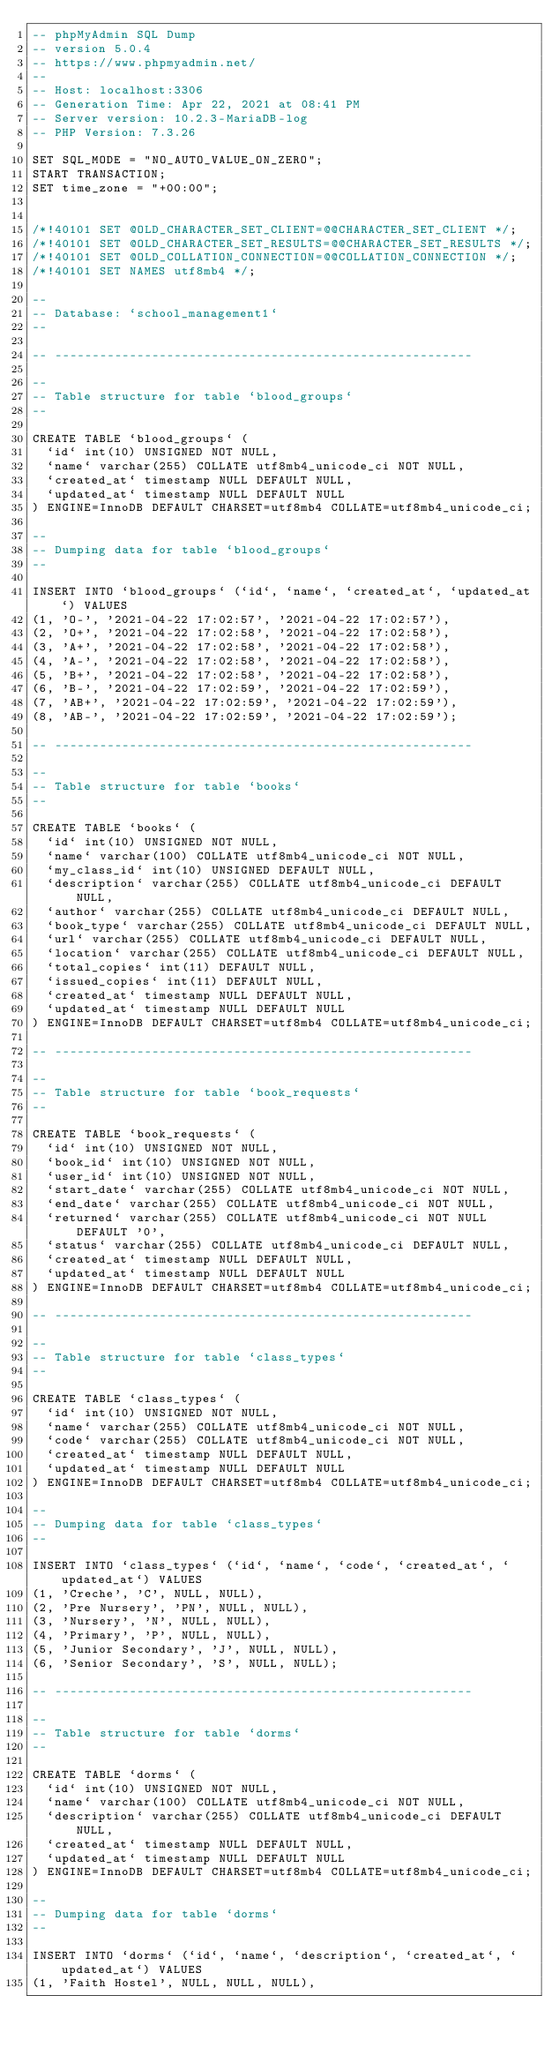<code> <loc_0><loc_0><loc_500><loc_500><_SQL_>-- phpMyAdmin SQL Dump
-- version 5.0.4
-- https://www.phpmyadmin.net/
--
-- Host: localhost:3306
-- Generation Time: Apr 22, 2021 at 08:41 PM
-- Server version: 10.2.3-MariaDB-log
-- PHP Version: 7.3.26

SET SQL_MODE = "NO_AUTO_VALUE_ON_ZERO";
START TRANSACTION;
SET time_zone = "+00:00";


/*!40101 SET @OLD_CHARACTER_SET_CLIENT=@@CHARACTER_SET_CLIENT */;
/*!40101 SET @OLD_CHARACTER_SET_RESULTS=@@CHARACTER_SET_RESULTS */;
/*!40101 SET @OLD_COLLATION_CONNECTION=@@COLLATION_CONNECTION */;
/*!40101 SET NAMES utf8mb4 */;

--
-- Database: `school_management1`
--

-- --------------------------------------------------------

--
-- Table structure for table `blood_groups`
--

CREATE TABLE `blood_groups` (
  `id` int(10) UNSIGNED NOT NULL,
  `name` varchar(255) COLLATE utf8mb4_unicode_ci NOT NULL,
  `created_at` timestamp NULL DEFAULT NULL,
  `updated_at` timestamp NULL DEFAULT NULL
) ENGINE=InnoDB DEFAULT CHARSET=utf8mb4 COLLATE=utf8mb4_unicode_ci;

--
-- Dumping data for table `blood_groups`
--

INSERT INTO `blood_groups` (`id`, `name`, `created_at`, `updated_at`) VALUES
(1, 'O-', '2021-04-22 17:02:57', '2021-04-22 17:02:57'),
(2, 'O+', '2021-04-22 17:02:58', '2021-04-22 17:02:58'),
(3, 'A+', '2021-04-22 17:02:58', '2021-04-22 17:02:58'),
(4, 'A-', '2021-04-22 17:02:58', '2021-04-22 17:02:58'),
(5, 'B+', '2021-04-22 17:02:58', '2021-04-22 17:02:58'),
(6, 'B-', '2021-04-22 17:02:59', '2021-04-22 17:02:59'),
(7, 'AB+', '2021-04-22 17:02:59', '2021-04-22 17:02:59'),
(8, 'AB-', '2021-04-22 17:02:59', '2021-04-22 17:02:59');

-- --------------------------------------------------------

--
-- Table structure for table `books`
--

CREATE TABLE `books` (
  `id` int(10) UNSIGNED NOT NULL,
  `name` varchar(100) COLLATE utf8mb4_unicode_ci NOT NULL,
  `my_class_id` int(10) UNSIGNED DEFAULT NULL,
  `description` varchar(255) COLLATE utf8mb4_unicode_ci DEFAULT NULL,
  `author` varchar(255) COLLATE utf8mb4_unicode_ci DEFAULT NULL,
  `book_type` varchar(255) COLLATE utf8mb4_unicode_ci DEFAULT NULL,
  `url` varchar(255) COLLATE utf8mb4_unicode_ci DEFAULT NULL,
  `location` varchar(255) COLLATE utf8mb4_unicode_ci DEFAULT NULL,
  `total_copies` int(11) DEFAULT NULL,
  `issued_copies` int(11) DEFAULT NULL,
  `created_at` timestamp NULL DEFAULT NULL,
  `updated_at` timestamp NULL DEFAULT NULL
) ENGINE=InnoDB DEFAULT CHARSET=utf8mb4 COLLATE=utf8mb4_unicode_ci;

-- --------------------------------------------------------

--
-- Table structure for table `book_requests`
--

CREATE TABLE `book_requests` (
  `id` int(10) UNSIGNED NOT NULL,
  `book_id` int(10) UNSIGNED NOT NULL,
  `user_id` int(10) UNSIGNED NOT NULL,
  `start_date` varchar(255) COLLATE utf8mb4_unicode_ci NOT NULL,
  `end_date` varchar(255) COLLATE utf8mb4_unicode_ci NOT NULL,
  `returned` varchar(255) COLLATE utf8mb4_unicode_ci NOT NULL DEFAULT '0',
  `status` varchar(255) COLLATE utf8mb4_unicode_ci DEFAULT NULL,
  `created_at` timestamp NULL DEFAULT NULL,
  `updated_at` timestamp NULL DEFAULT NULL
) ENGINE=InnoDB DEFAULT CHARSET=utf8mb4 COLLATE=utf8mb4_unicode_ci;

-- --------------------------------------------------------

--
-- Table structure for table `class_types`
--

CREATE TABLE `class_types` (
  `id` int(10) UNSIGNED NOT NULL,
  `name` varchar(255) COLLATE utf8mb4_unicode_ci NOT NULL,
  `code` varchar(255) COLLATE utf8mb4_unicode_ci NOT NULL,
  `created_at` timestamp NULL DEFAULT NULL,
  `updated_at` timestamp NULL DEFAULT NULL
) ENGINE=InnoDB DEFAULT CHARSET=utf8mb4 COLLATE=utf8mb4_unicode_ci;

--
-- Dumping data for table `class_types`
--

INSERT INTO `class_types` (`id`, `name`, `code`, `created_at`, `updated_at`) VALUES
(1, 'Creche', 'C', NULL, NULL),
(2, 'Pre Nursery', 'PN', NULL, NULL),
(3, 'Nursery', 'N', NULL, NULL),
(4, 'Primary', 'P', NULL, NULL),
(5, 'Junior Secondary', 'J', NULL, NULL),
(6, 'Senior Secondary', 'S', NULL, NULL);

-- --------------------------------------------------------

--
-- Table structure for table `dorms`
--

CREATE TABLE `dorms` (
  `id` int(10) UNSIGNED NOT NULL,
  `name` varchar(100) COLLATE utf8mb4_unicode_ci NOT NULL,
  `description` varchar(255) COLLATE utf8mb4_unicode_ci DEFAULT NULL,
  `created_at` timestamp NULL DEFAULT NULL,
  `updated_at` timestamp NULL DEFAULT NULL
) ENGINE=InnoDB DEFAULT CHARSET=utf8mb4 COLLATE=utf8mb4_unicode_ci;

--
-- Dumping data for table `dorms`
--

INSERT INTO `dorms` (`id`, `name`, `description`, `created_at`, `updated_at`) VALUES
(1, 'Faith Hostel', NULL, NULL, NULL),</code> 